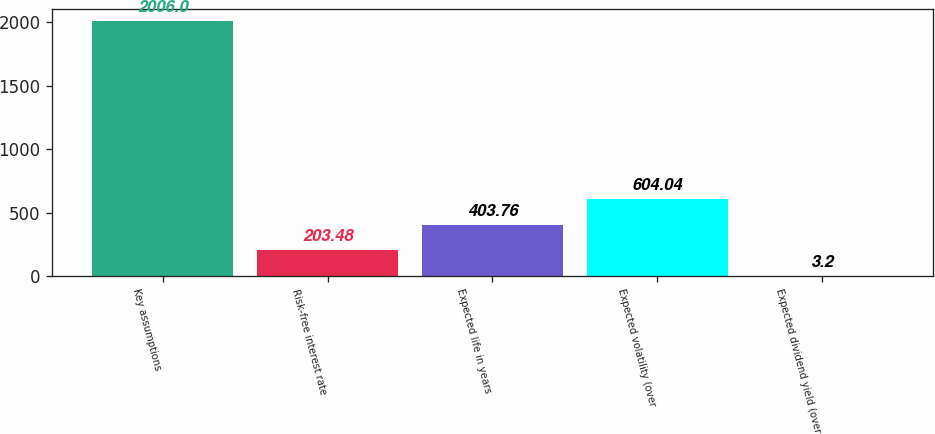<chart> <loc_0><loc_0><loc_500><loc_500><bar_chart><fcel>Key assumptions<fcel>Risk-free interest rate<fcel>Expected life in years<fcel>Expected volatility (over<fcel>Expected dividend yield (over<nl><fcel>2006<fcel>203.48<fcel>403.76<fcel>604.04<fcel>3.2<nl></chart> 